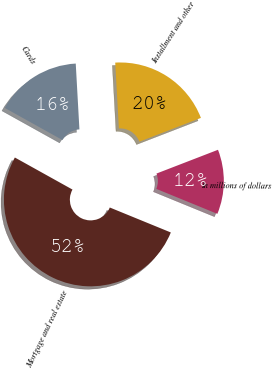Convert chart. <chart><loc_0><loc_0><loc_500><loc_500><pie_chart><fcel>In millions of dollars<fcel>Mortgage and real estate<fcel>Cards<fcel>Installment and other<nl><fcel>12.05%<fcel>51.9%<fcel>16.03%<fcel>20.02%<nl></chart> 